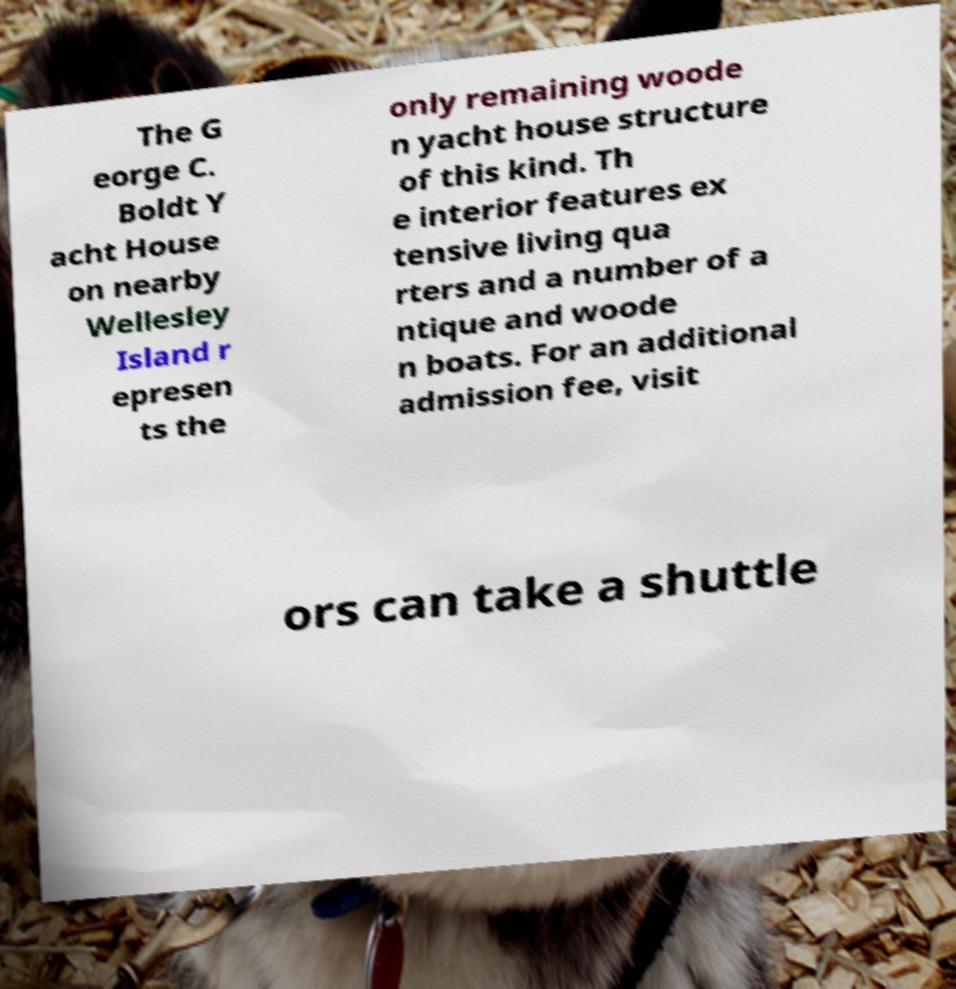I need the written content from this picture converted into text. Can you do that? The G eorge C. Boldt Y acht House on nearby Wellesley Island r epresen ts the only remaining woode n yacht house structure of this kind. Th e interior features ex tensive living qua rters and a number of a ntique and woode n boats. For an additional admission fee, visit ors can take a shuttle 